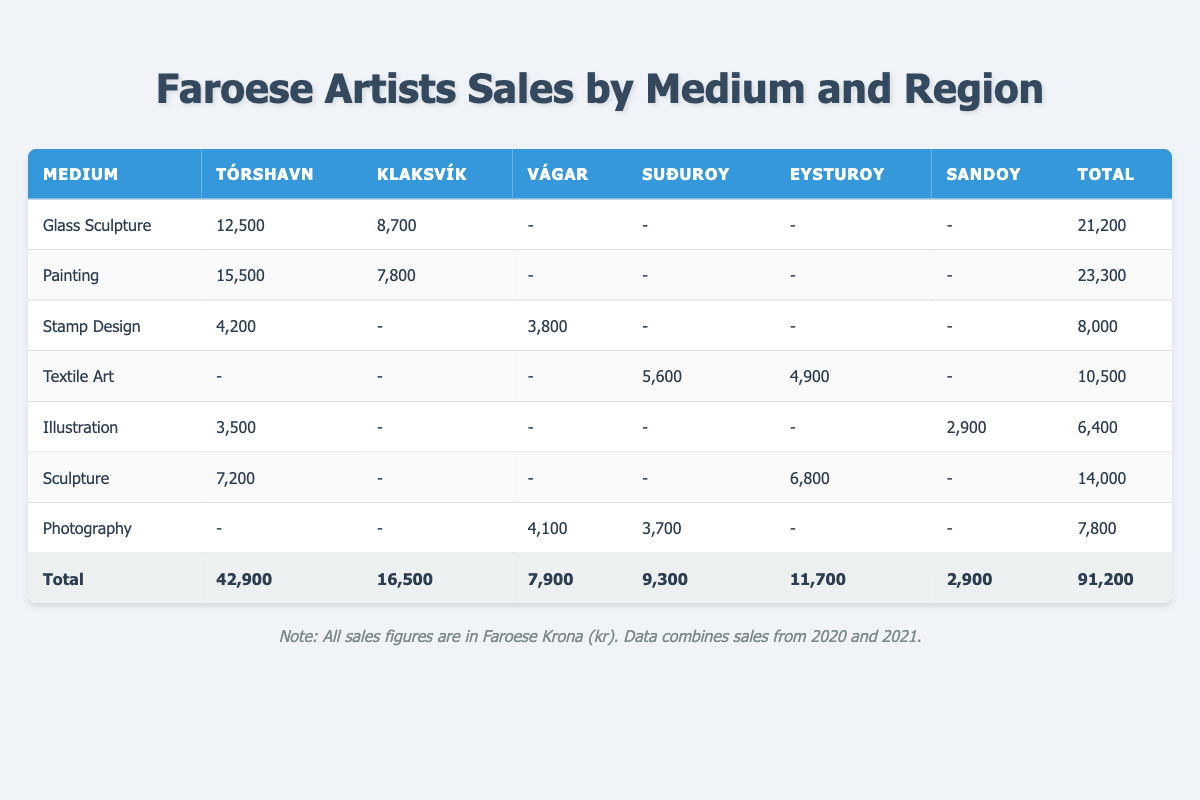What is the total sales for Glass Sculpture in Tórshavn? In the table, for the medium "Glass Sculpture," the sales in Tórshavn is listed as 12,500.
Answer: 12,500 Which medium had the highest total sales across all regions? To find this, we need to look at the total sales for each medium: Glass Sculpture (21,200), Painting (23,300), Stamp Design (8,000), Textile Art (10,500), Illustration (6,400), Sculpture (14,000), and Photography (7,800). The highest total is for Painting, with 23,300.
Answer: Painting Was any medium sold in Sandoy? The table shows sales for Illustration in Sandoy for 2,900. Therefore, yes, there was a sale in Sandoy.
Answer: Yes What is the difference in total sales between Tórshavn and Klaksvík? The total sales for Tórshavn is 42,900 and for Klaksvík is 16,500. To find the difference, we subtract: 42,900 - 16,500 = 26,400.
Answer: 26,400 How much was sold in total for Eysturoy across all mediums? In the Eysturoy column, the sales figures are 6,800 (Sculpture) and 4,900 (Textile Art). Adding them gives: 6,800 + 4,900 = 11,700.
Answer: 11,700 Which artist had the highest sales in Tórshavn? In Tórshavn, the sales figures are 12,500 (Tróndur Patursson - Glass Sculpture), 15,500 (Rannvá Kunoy - Painting), and 3,500 (Edward Fuglø - Illustration). The highest is 15,500 by Rannvá Kunoy.
Answer: Rannvá Kunoy What percentage of total sales came from Photography? Total sales from Photography are 7,800, and the overall total sales are 91,200. To find the percentage: (7,800 / 91,200) * 100 = 8.56%.
Answer: 8.56% In which year did Tróndur Patursson achieve higher sales, 2020 or 2021? In 2020, Tróndur Patursson sold 12,500 (Glass Sculpture) and 8,700 (Klaksvík). In 2021, he sold 6,300 (Painting). Total for 2020 is 21,200, and for 2021 is 6,300. 21,200 is higher.
Answer: 2020 What is the overall average sales per region across all mediums? The total sales are 91,200 and there are 6 regions (Tórshavn, Klaksvík, Vágar, Suðuroy, Eysturoy, Sandoy). To find the overall average sales per region: 91,200 / 6 = 15,200.
Answer: 15,200 